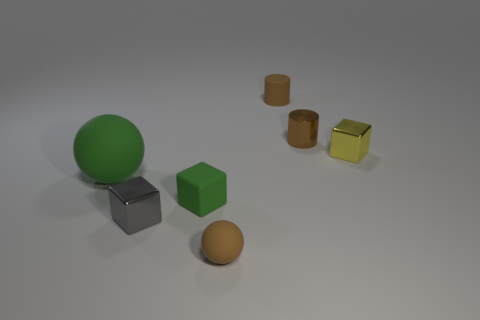Add 2 tiny objects. How many objects exist? 9 Subtract all cylinders. How many objects are left? 5 Add 4 brown shiny objects. How many brown shiny objects exist? 5 Subtract 1 gray blocks. How many objects are left? 6 Subtract all yellow blocks. Subtract all small brown rubber objects. How many objects are left? 4 Add 2 shiny cylinders. How many shiny cylinders are left? 3 